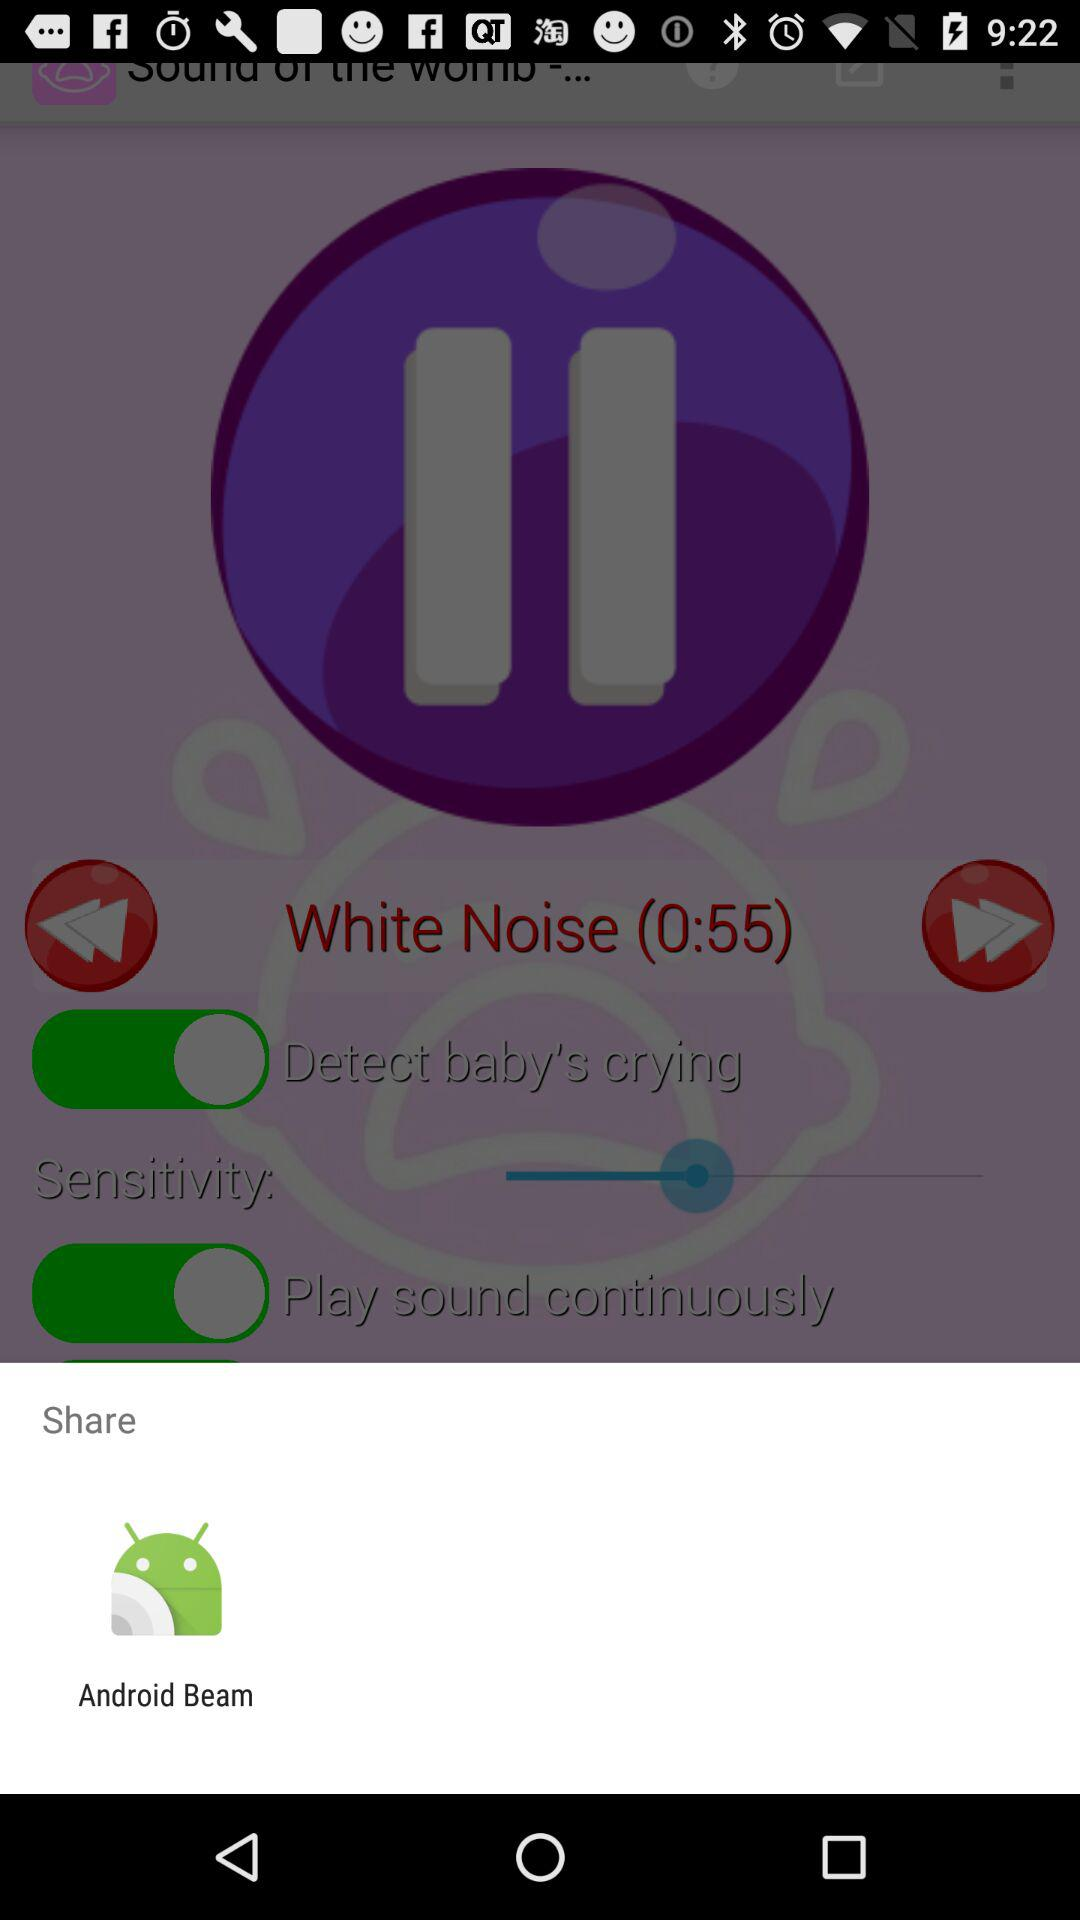By using what application can we share? You can share by using "Android Beam". 